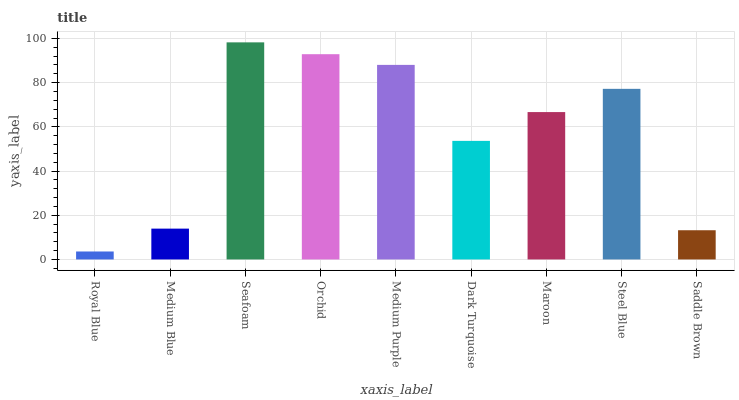Is Medium Blue the minimum?
Answer yes or no. No. Is Medium Blue the maximum?
Answer yes or no. No. Is Medium Blue greater than Royal Blue?
Answer yes or no. Yes. Is Royal Blue less than Medium Blue?
Answer yes or no. Yes. Is Royal Blue greater than Medium Blue?
Answer yes or no. No. Is Medium Blue less than Royal Blue?
Answer yes or no. No. Is Maroon the high median?
Answer yes or no. Yes. Is Maroon the low median?
Answer yes or no. Yes. Is Orchid the high median?
Answer yes or no. No. Is Royal Blue the low median?
Answer yes or no. No. 